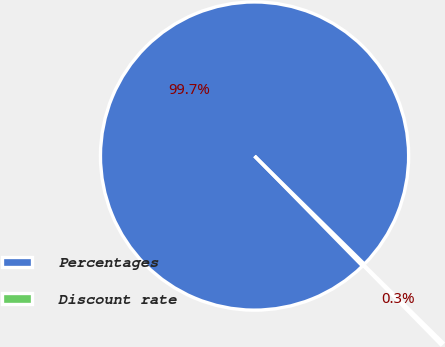<chart> <loc_0><loc_0><loc_500><loc_500><pie_chart><fcel>Percentages<fcel>Discount rate<nl><fcel>99.71%<fcel>0.29%<nl></chart> 